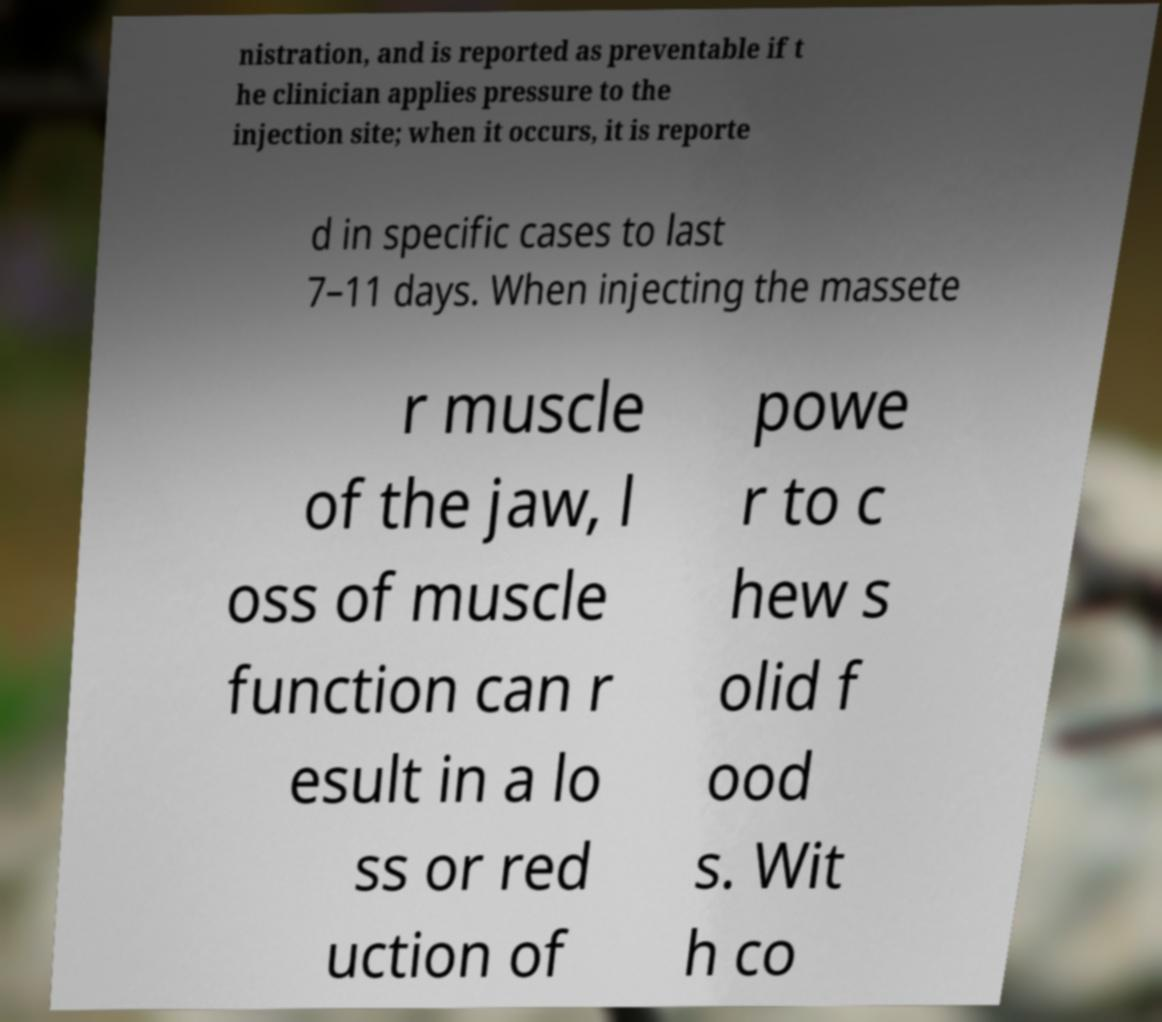Can you accurately transcribe the text from the provided image for me? nistration, and is reported as preventable if t he clinician applies pressure to the injection site; when it occurs, it is reporte d in specific cases to last 7–11 days. When injecting the massete r muscle of the jaw, l oss of muscle function can r esult in a lo ss or red uction of powe r to c hew s olid f ood s. Wit h co 